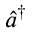Convert formula to latex. <formula><loc_0><loc_0><loc_500><loc_500>\hat { a } ^ { \dagger }</formula> 